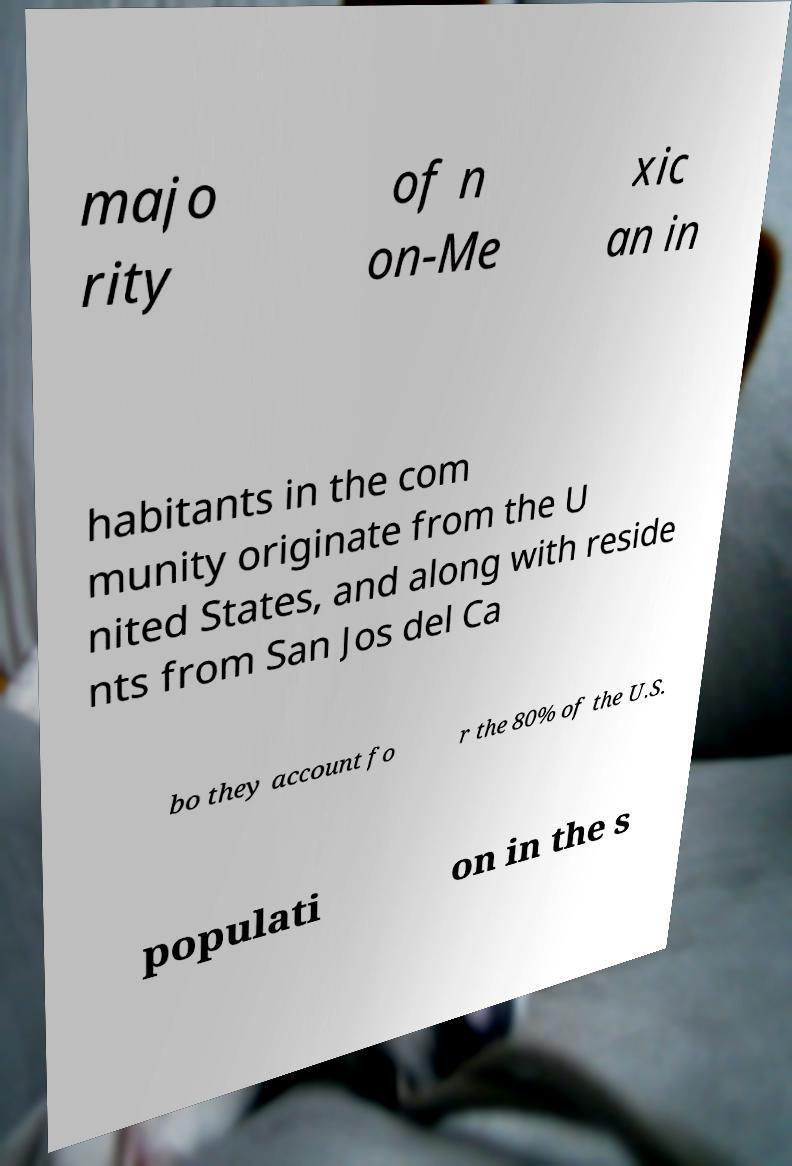Please read and relay the text visible in this image. What does it say? majo rity of n on-Me xic an in habitants in the com munity originate from the U nited States, and along with reside nts from San Jos del Ca bo they account fo r the 80% of the U.S. populati on in the s 